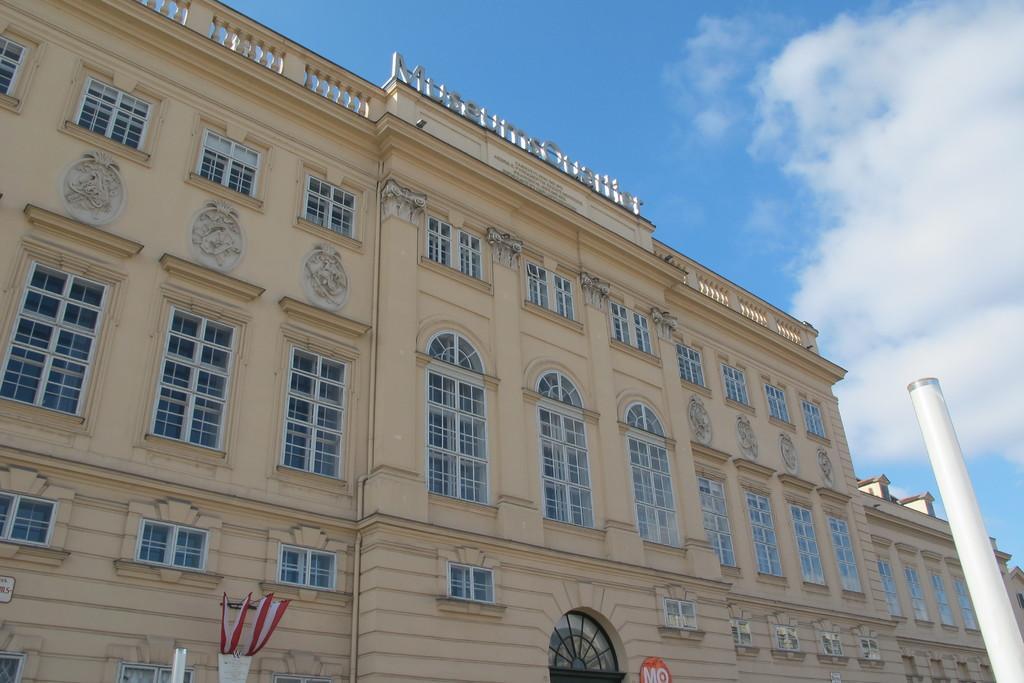How would you summarize this image in a sentence or two? In this picture we can see a building, here we can see a pole, poster, pot, some objects and we can see sky in the background. 